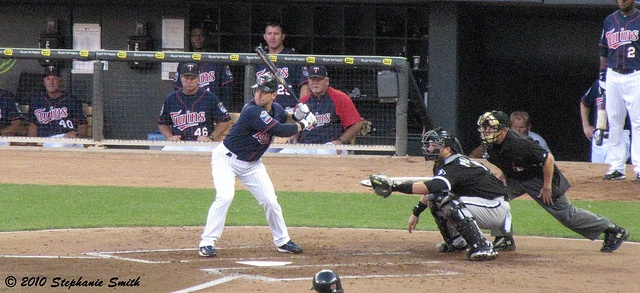Describe the objects in this image and their specific colors. I can see people in black, white, and gray tones, people in black, gray, lightgray, and darkgray tones, people in black, gray, darkgray, and olive tones, people in black, lavender, navy, and gray tones, and people in black and gray tones in this image. 